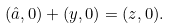Convert formula to latex. <formula><loc_0><loc_0><loc_500><loc_500>( \hat { a } , 0 ) + ( y , 0 ) = ( z , 0 ) .</formula> 